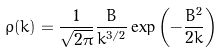Convert formula to latex. <formula><loc_0><loc_0><loc_500><loc_500>\rho ( k ) = \frac { 1 } { \sqrt { 2 \pi } } \frac { B } { k ^ { 3 / 2 } } \exp \left ( - \frac { B ^ { 2 } } { 2 k } \right )</formula> 